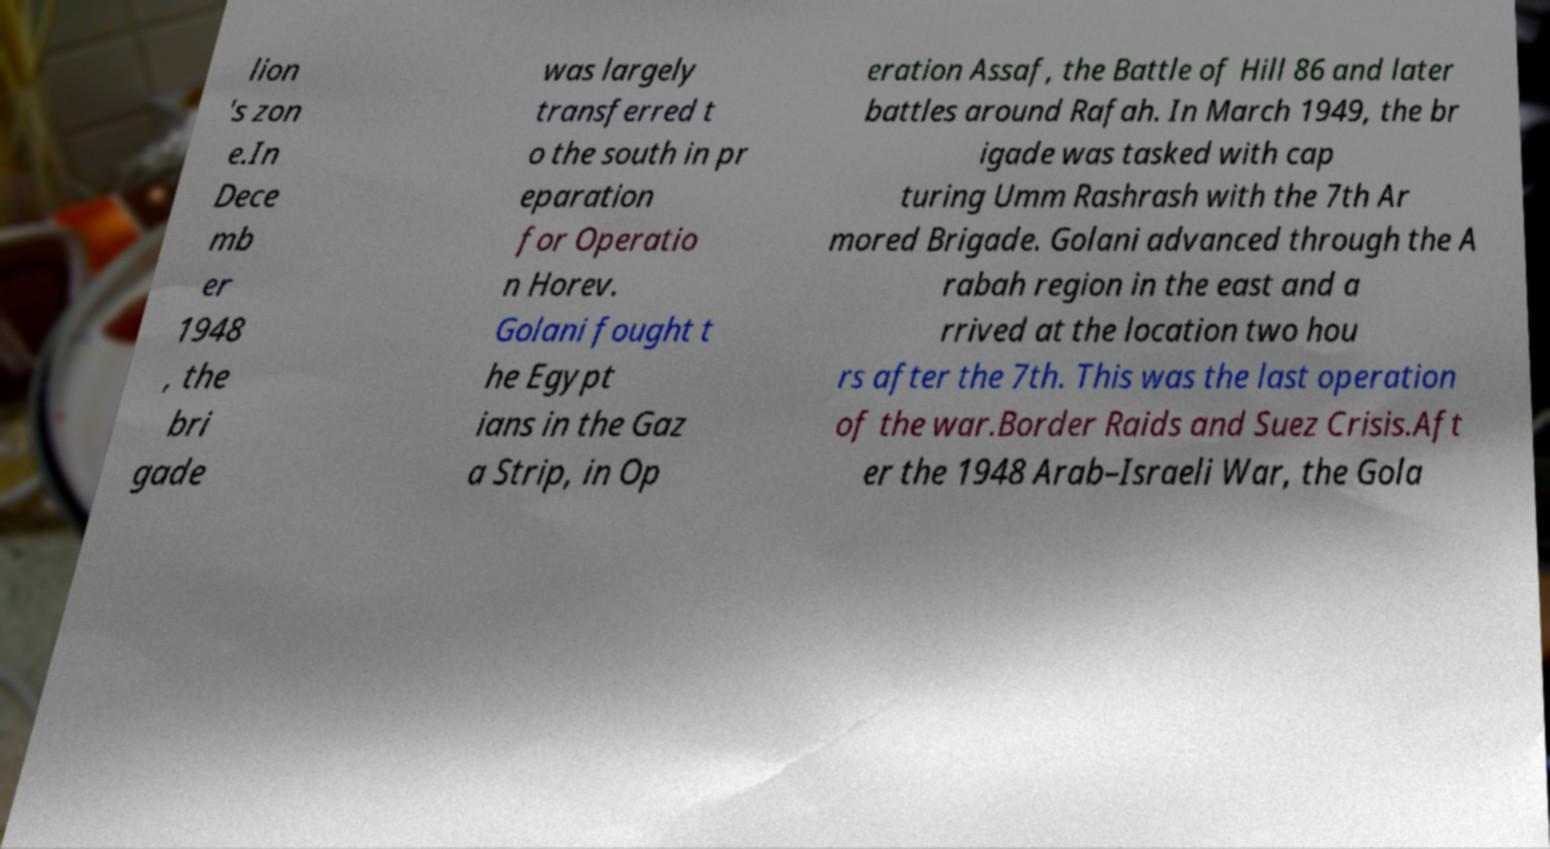I need the written content from this picture converted into text. Can you do that? lion 's zon e.In Dece mb er 1948 , the bri gade was largely transferred t o the south in pr eparation for Operatio n Horev. Golani fought t he Egypt ians in the Gaz a Strip, in Op eration Assaf, the Battle of Hill 86 and later battles around Rafah. In March 1949, the br igade was tasked with cap turing Umm Rashrash with the 7th Ar mored Brigade. Golani advanced through the A rabah region in the east and a rrived at the location two hou rs after the 7th. This was the last operation of the war.Border Raids and Suez Crisis.Aft er the 1948 Arab–Israeli War, the Gola 